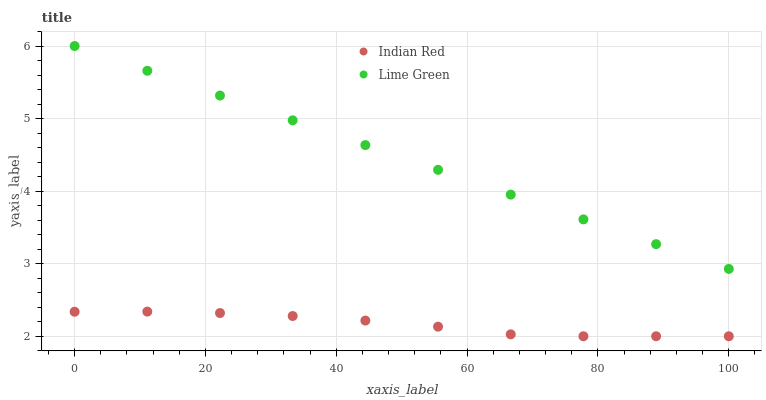Does Indian Red have the minimum area under the curve?
Answer yes or no. Yes. Does Lime Green have the maximum area under the curve?
Answer yes or no. Yes. Does Indian Red have the maximum area under the curve?
Answer yes or no. No. Is Lime Green the smoothest?
Answer yes or no. Yes. Is Indian Red the roughest?
Answer yes or no. Yes. Is Indian Red the smoothest?
Answer yes or no. No. Does Indian Red have the lowest value?
Answer yes or no. Yes. Does Lime Green have the highest value?
Answer yes or no. Yes. Does Indian Red have the highest value?
Answer yes or no. No. Is Indian Red less than Lime Green?
Answer yes or no. Yes. Is Lime Green greater than Indian Red?
Answer yes or no. Yes. Does Indian Red intersect Lime Green?
Answer yes or no. No. 